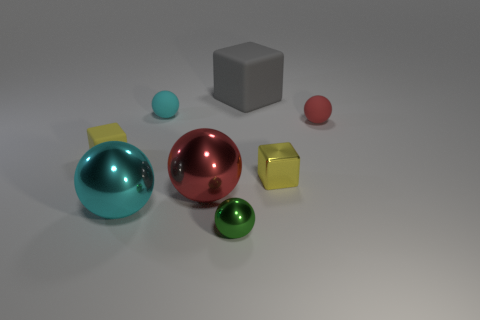Subtract 2 spheres. How many spheres are left? 3 Subtract all green balls. How many balls are left? 4 Subtract all tiny green spheres. How many spheres are left? 4 Subtract all blue balls. Subtract all gray cylinders. How many balls are left? 5 Add 2 large shiny spheres. How many objects exist? 10 Subtract all blocks. How many objects are left? 5 Subtract all large matte blocks. Subtract all cyan spheres. How many objects are left? 5 Add 6 gray objects. How many gray objects are left? 7 Add 1 small green balls. How many small green balls exist? 2 Subtract 0 brown cylinders. How many objects are left? 8 